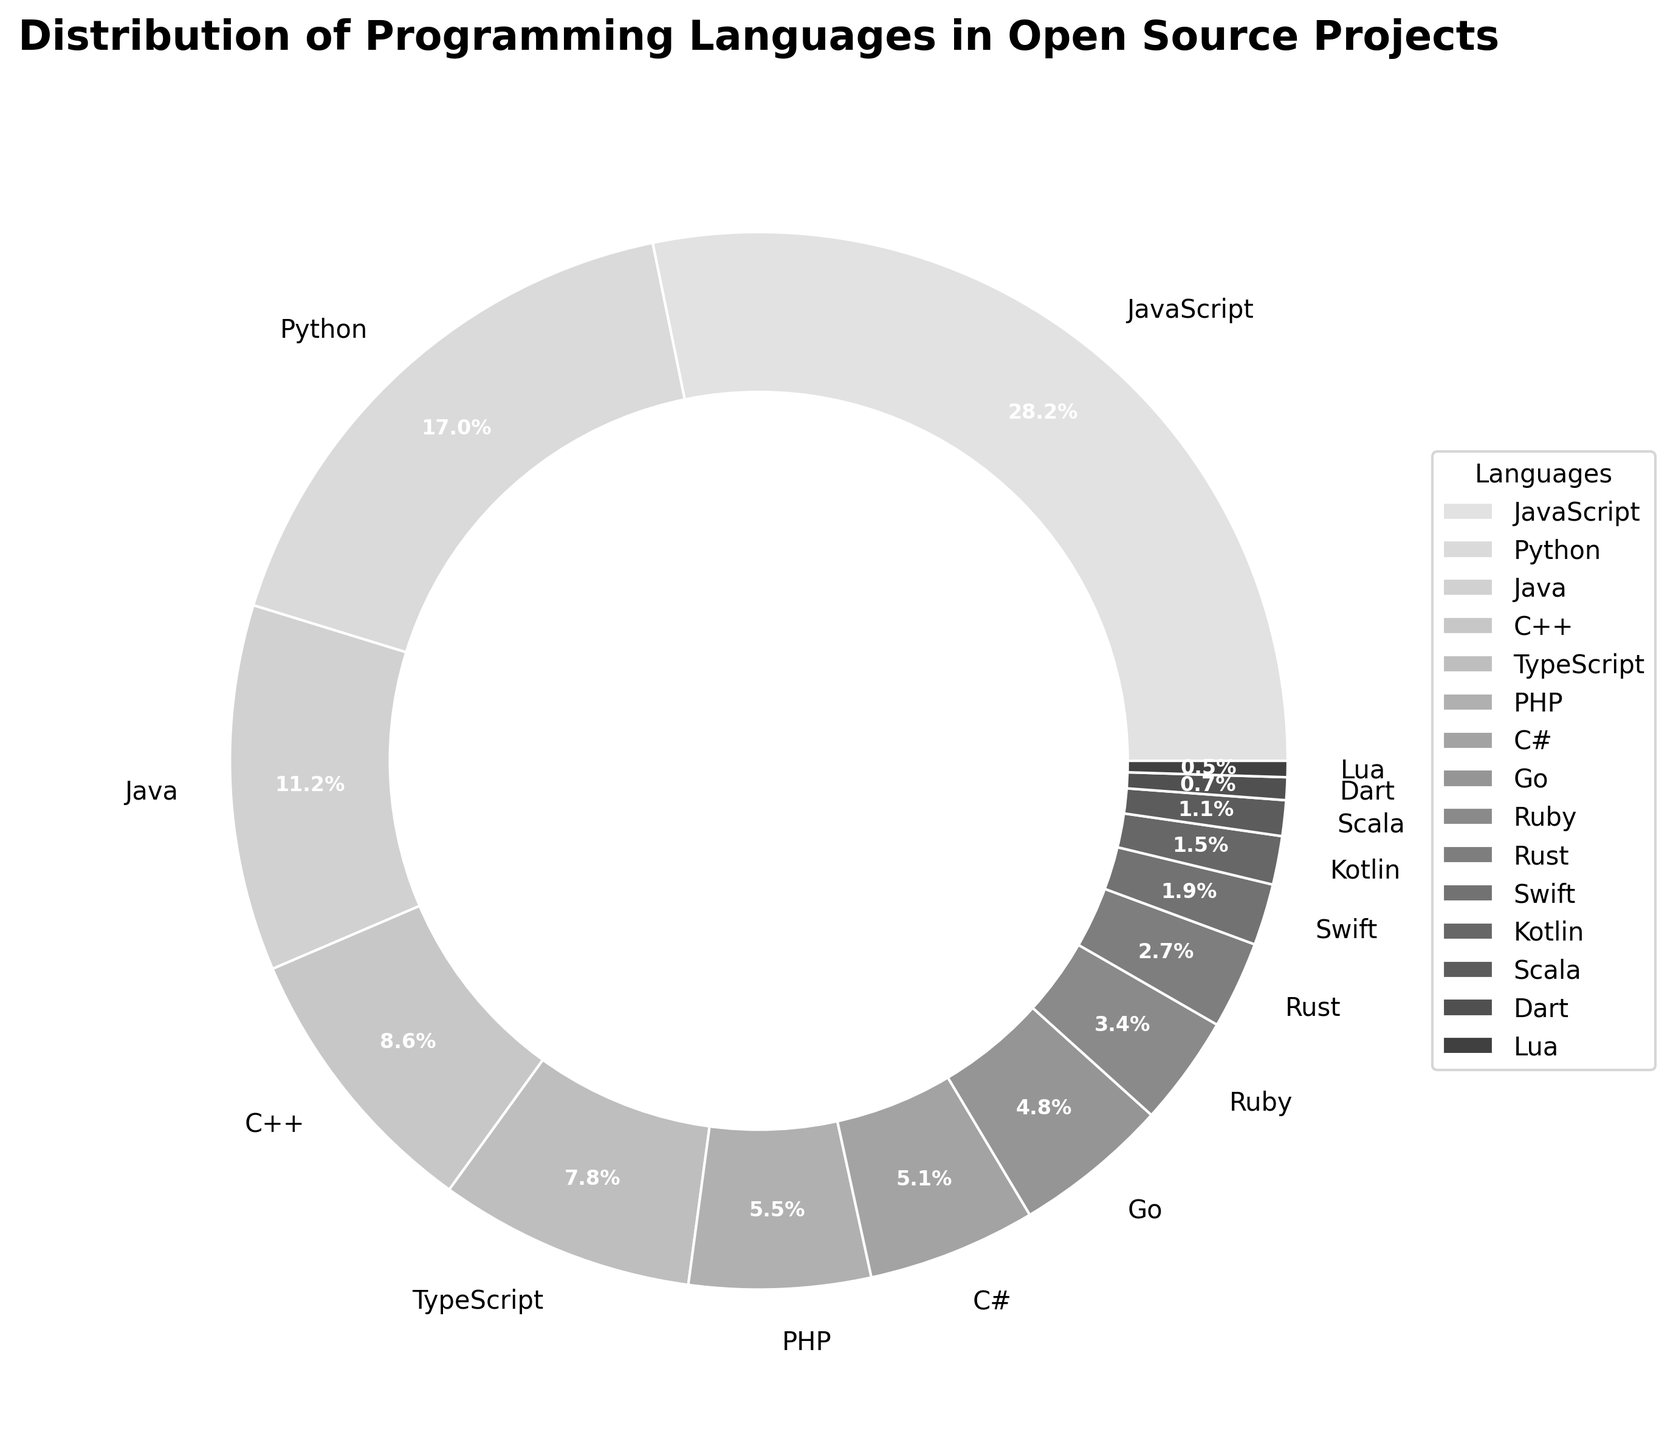Which programming language has the highest percentage of use in open source projects? By observing the pie chart, we can see that JavaScript has the largest segment. This indicates that JavaScript is the most popular language among open source contributors as it occupies the largest portion of the pie chart.
Answer: JavaScript Which is more popular in open source projects, Python or Java? We can compare the sizes of the segments labeled Python and Java. Python has a larger segment with a 17.2% share as opposed to Java's 11.3% share. Therefore, Python is more popular.
Answer: Python What is the combined percentage of the top 3 most used programming languages in open source projects? The top 3 languages are JavaScript (28.5%), Python (17.2%), and Java (11.3%). Adding these percentages together: 28.5% + 17.2% + 11.3% = 57%.
Answer: 57% How does the usage of C++ compare to PHP in open source projects? Looking at the segments for C++ and PHP, C++ has 8.7% and PHP has 5.6%. Since 8.7% is greater than 5.6%, C++ is used more than PHP.
Answer: C++ is used more What is the least used programming language shown in the pie chart? By examining the pie chart, we notice Lua has the smallest segment, which occupies 0.5% of the pie. Thus, Lua is the least used language.
Answer: Lua Calculate the difference in usage between TypeScript and Swift. TypeScript has a share of 7.9% and Swift has 1.9%. Subtracting these values: 7.9% - 1.9% = 6%.
Answer: 6% What percentage of open source projects use languages other than the top 5 listed? The top 5 languages are JavaScript, Python, Java, C++, and TypeScript, which sum up to: 28.5% + 17.2% + 11.3% + 8.7% + 7.9% = 73.6%. The percentage using languages outside the top 5 is 100% - 73.6% = 26.4%.
Answer: 26.4% Are there any languages used by less than 1% of open source projects? Referring to the pie chart, Dart (0.7%) and Lua (0.5%) are both used by less than 1% of open source projects.
Answer: Yes, Dart and Lua How do the usages of Go and C# compare? By looking at the segments for Go and C#, Go has 4.8% and C# has 5.2%. Since 5.2% is slightly greater than 4.8%, C# is used more than Go.
Answer: C# is used more What is the average percentage use of Ruby and Rust in open source projects? Ruby has 3.4% and Rust has 2.7%. Adding these together and then dividing by 2 gives: (3.4% + 2.7%) / 2 = 6.1% / 2 = 3.05%.
Answer: 3.05% 